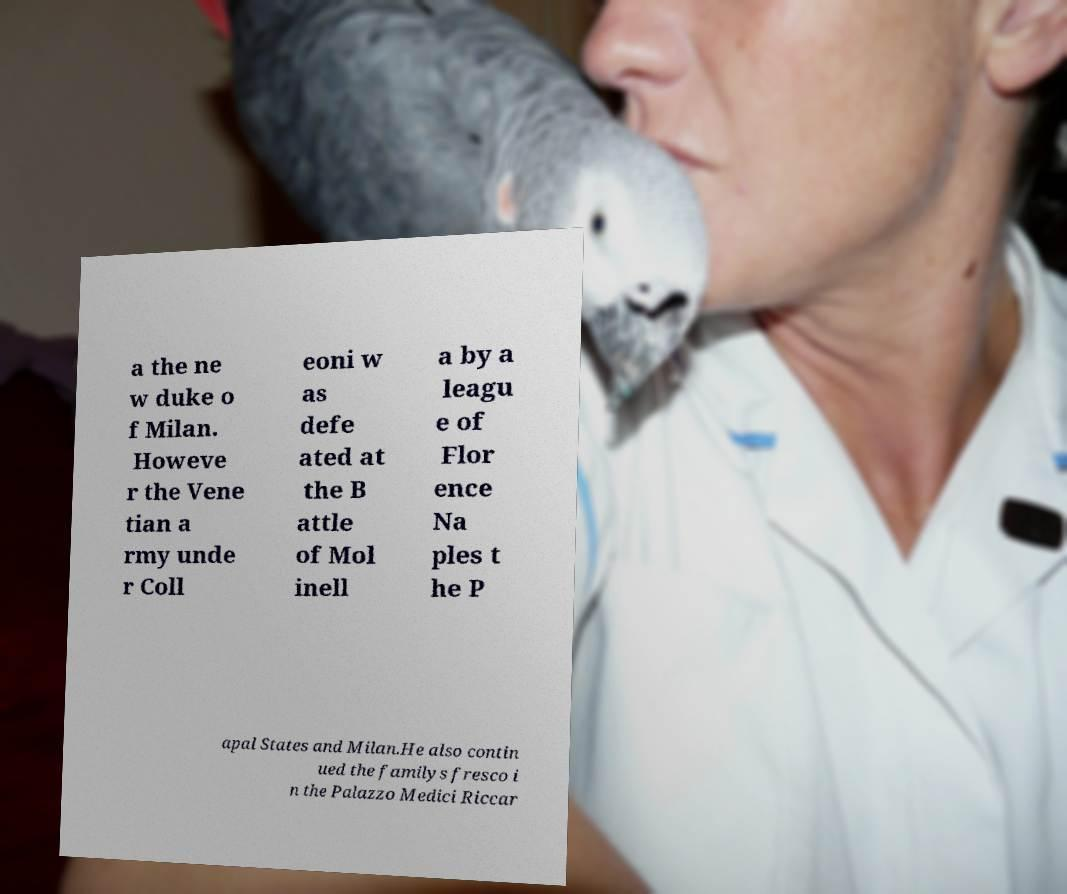Could you extract and type out the text from this image? a the ne w duke o f Milan. Howeve r the Vene tian a rmy unde r Coll eoni w as defe ated at the B attle of Mol inell a by a leagu e of Flor ence Na ples t he P apal States and Milan.He also contin ued the familys fresco i n the Palazzo Medici Riccar 